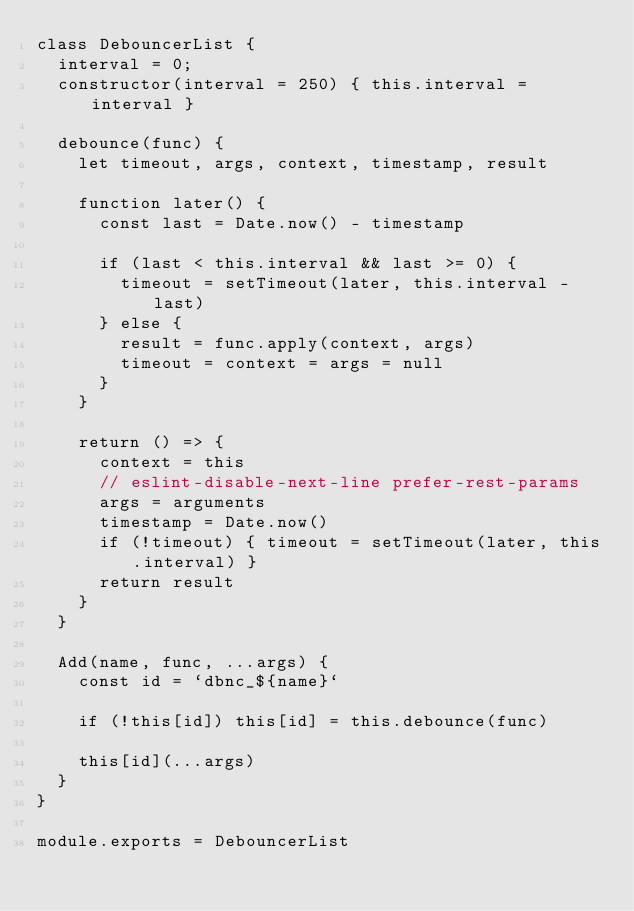Convert code to text. <code><loc_0><loc_0><loc_500><loc_500><_JavaScript_>class DebouncerList {
  interval = 0;
  constructor(interval = 250) { this.interval = interval }

  debounce(func) {
    let timeout, args, context, timestamp, result

    function later() {
      const last = Date.now() - timestamp

      if (last < this.interval && last >= 0) {
        timeout = setTimeout(later, this.interval - last)
      } else {
        result = func.apply(context, args)
        timeout = context = args = null
      }
    }

    return () => {
      context = this
      // eslint-disable-next-line prefer-rest-params
      args = arguments
      timestamp = Date.now()
      if (!timeout) { timeout = setTimeout(later, this.interval) }
      return result
    }
  }

  Add(name, func, ...args) {
    const id = `dbnc_${name}`

    if (!this[id]) this[id] = this.debounce(func)

    this[id](...args)
  }
}

module.exports = DebouncerList
</code> 